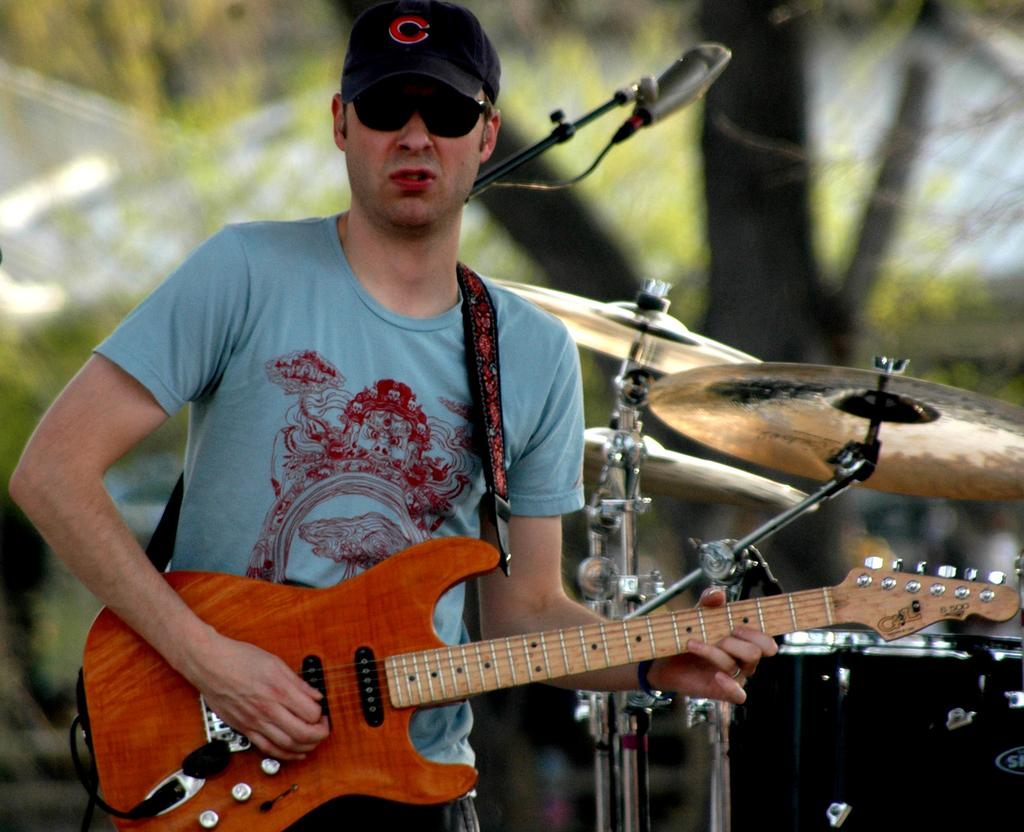What is the person in the image wearing? The person is wearing a blue shirt. What activity is the person engaged in? The person is playing a guitar. What device is placed in front of the person? There is a microphone placed in front of the person. What can be seen in the background of the image? There are several musical instruments in the background. What type of comb does the person's dad use in the image? There is no information about a comb or the person's dad in the image, so we cannot answer that question. What appliance is the person using to play the guitar in the image? The image does not show any appliances being used to play the guitar; the person is simply playing the guitar by hand. 